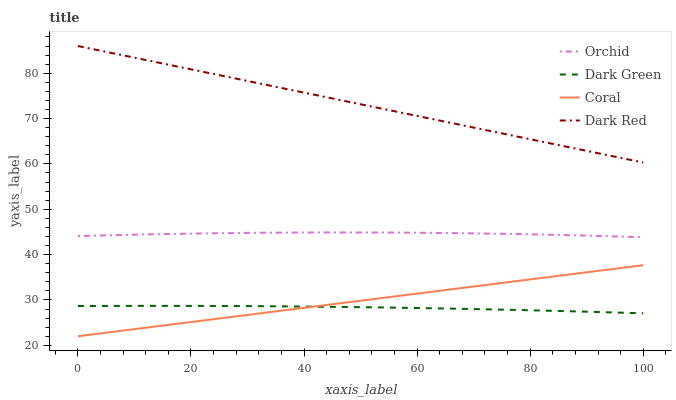Does Dark Green have the minimum area under the curve?
Answer yes or no. Yes. Does Dark Red have the maximum area under the curve?
Answer yes or no. Yes. Does Coral have the minimum area under the curve?
Answer yes or no. No. Does Coral have the maximum area under the curve?
Answer yes or no. No. Is Coral the smoothest?
Answer yes or no. Yes. Is Orchid the roughest?
Answer yes or no. Yes. Is Dark Green the smoothest?
Answer yes or no. No. Is Dark Green the roughest?
Answer yes or no. No. Does Dark Green have the lowest value?
Answer yes or no. No. Does Coral have the highest value?
Answer yes or no. No. Is Dark Green less than Orchid?
Answer yes or no. Yes. Is Orchid greater than Dark Green?
Answer yes or no. Yes. Does Dark Green intersect Orchid?
Answer yes or no. No. 